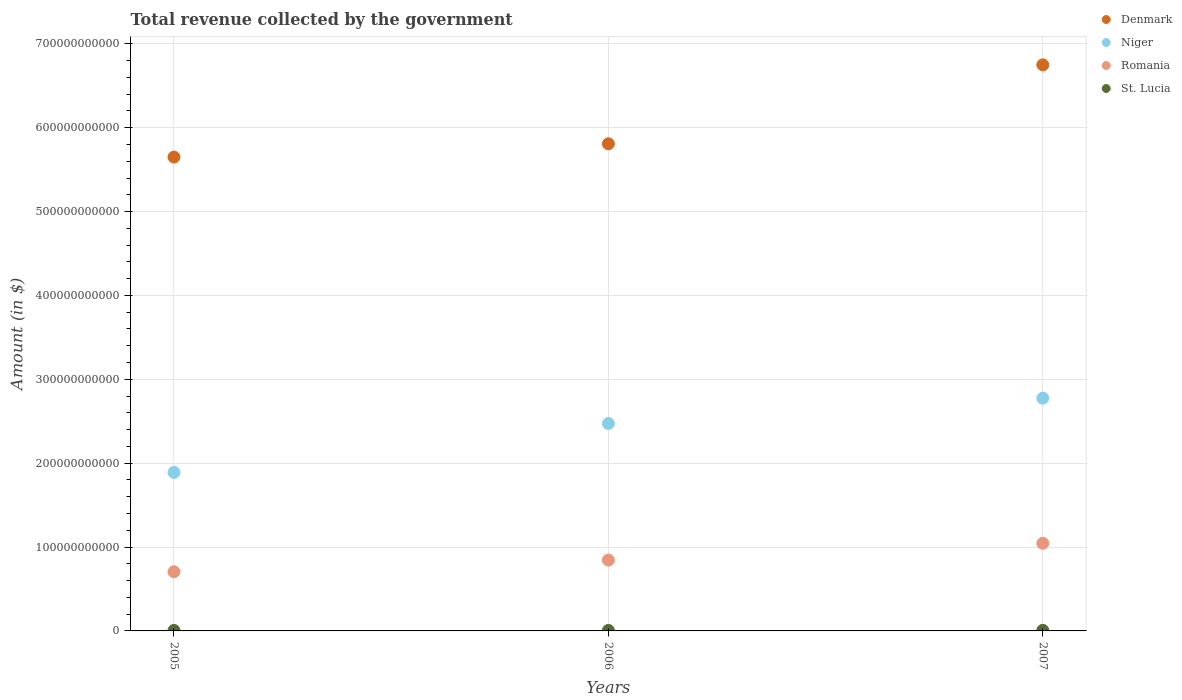What is the total revenue collected by the government in Denmark in 2006?
Offer a terse response. 5.81e+11. Across all years, what is the maximum total revenue collected by the government in St. Lucia?
Your response must be concise. 7.03e+08. Across all years, what is the minimum total revenue collected by the government in Niger?
Your response must be concise. 1.89e+11. In which year was the total revenue collected by the government in Romania maximum?
Your answer should be compact. 2007. What is the total total revenue collected by the government in Romania in the graph?
Offer a terse response. 2.59e+11. What is the difference between the total revenue collected by the government in St. Lucia in 2005 and that in 2006?
Your answer should be compact. -7.08e+07. What is the difference between the total revenue collected by the government in Denmark in 2006 and the total revenue collected by the government in Niger in 2007?
Offer a very short reply. 3.03e+11. What is the average total revenue collected by the government in St. Lucia per year?
Ensure brevity in your answer.  6.43e+08. In the year 2007, what is the difference between the total revenue collected by the government in Romania and total revenue collected by the government in St. Lucia?
Provide a short and direct response. 1.04e+11. In how many years, is the total revenue collected by the government in Romania greater than 460000000000 $?
Ensure brevity in your answer.  0. What is the ratio of the total revenue collected by the government in Denmark in 2005 to that in 2007?
Ensure brevity in your answer.  0.84. Is the total revenue collected by the government in St. Lucia in 2005 less than that in 2007?
Offer a terse response. Yes. What is the difference between the highest and the second highest total revenue collected by the government in Romania?
Your response must be concise. 2.00e+1. What is the difference between the highest and the lowest total revenue collected by the government in Niger?
Make the answer very short. 8.85e+1. Is it the case that in every year, the sum of the total revenue collected by the government in Niger and total revenue collected by the government in Denmark  is greater than the total revenue collected by the government in Romania?
Your answer should be compact. Yes. Does the total revenue collected by the government in St. Lucia monotonically increase over the years?
Make the answer very short. Yes. Is the total revenue collected by the government in Denmark strictly greater than the total revenue collected by the government in Niger over the years?
Make the answer very short. Yes. Is the total revenue collected by the government in St. Lucia strictly less than the total revenue collected by the government in Denmark over the years?
Provide a short and direct response. Yes. How many years are there in the graph?
Ensure brevity in your answer.  3. What is the difference between two consecutive major ticks on the Y-axis?
Make the answer very short. 1.00e+11. Does the graph contain any zero values?
Your answer should be very brief. No. What is the title of the graph?
Make the answer very short. Total revenue collected by the government. Does "Armenia" appear as one of the legend labels in the graph?
Offer a terse response. No. What is the label or title of the Y-axis?
Your answer should be very brief. Amount (in $). What is the Amount (in $) in Denmark in 2005?
Your response must be concise. 5.65e+11. What is the Amount (in $) of Niger in 2005?
Offer a terse response. 1.89e+11. What is the Amount (in $) of Romania in 2005?
Give a very brief answer. 7.06e+1. What is the Amount (in $) of St. Lucia in 2005?
Your answer should be very brief. 5.77e+08. What is the Amount (in $) of Denmark in 2006?
Your answer should be very brief. 5.81e+11. What is the Amount (in $) in Niger in 2006?
Give a very brief answer. 2.47e+11. What is the Amount (in $) in Romania in 2006?
Provide a succinct answer. 8.45e+1. What is the Amount (in $) of St. Lucia in 2006?
Give a very brief answer. 6.48e+08. What is the Amount (in $) in Denmark in 2007?
Keep it short and to the point. 6.75e+11. What is the Amount (in $) of Niger in 2007?
Your response must be concise. 2.78e+11. What is the Amount (in $) in Romania in 2007?
Your response must be concise. 1.04e+11. What is the Amount (in $) of St. Lucia in 2007?
Your answer should be compact. 7.03e+08. Across all years, what is the maximum Amount (in $) in Denmark?
Offer a very short reply. 6.75e+11. Across all years, what is the maximum Amount (in $) of Niger?
Offer a very short reply. 2.78e+11. Across all years, what is the maximum Amount (in $) of Romania?
Offer a very short reply. 1.04e+11. Across all years, what is the maximum Amount (in $) in St. Lucia?
Provide a short and direct response. 7.03e+08. Across all years, what is the minimum Amount (in $) of Denmark?
Ensure brevity in your answer.  5.65e+11. Across all years, what is the minimum Amount (in $) of Niger?
Your response must be concise. 1.89e+11. Across all years, what is the minimum Amount (in $) of Romania?
Provide a succinct answer. 7.06e+1. Across all years, what is the minimum Amount (in $) of St. Lucia?
Your response must be concise. 5.77e+08. What is the total Amount (in $) of Denmark in the graph?
Offer a terse response. 1.82e+12. What is the total Amount (in $) in Niger in the graph?
Offer a terse response. 7.14e+11. What is the total Amount (in $) in Romania in the graph?
Provide a short and direct response. 2.59e+11. What is the total Amount (in $) of St. Lucia in the graph?
Your answer should be compact. 1.93e+09. What is the difference between the Amount (in $) of Denmark in 2005 and that in 2006?
Your response must be concise. -1.59e+1. What is the difference between the Amount (in $) of Niger in 2005 and that in 2006?
Ensure brevity in your answer.  -5.83e+1. What is the difference between the Amount (in $) of Romania in 2005 and that in 2006?
Provide a short and direct response. -1.39e+1. What is the difference between the Amount (in $) of St. Lucia in 2005 and that in 2006?
Ensure brevity in your answer.  -7.08e+07. What is the difference between the Amount (in $) of Denmark in 2005 and that in 2007?
Keep it short and to the point. -1.10e+11. What is the difference between the Amount (in $) in Niger in 2005 and that in 2007?
Offer a terse response. -8.85e+1. What is the difference between the Amount (in $) in Romania in 2005 and that in 2007?
Make the answer very short. -3.39e+1. What is the difference between the Amount (in $) of St. Lucia in 2005 and that in 2007?
Your response must be concise. -1.26e+08. What is the difference between the Amount (in $) in Denmark in 2006 and that in 2007?
Offer a very short reply. -9.41e+1. What is the difference between the Amount (in $) of Niger in 2006 and that in 2007?
Offer a terse response. -3.02e+1. What is the difference between the Amount (in $) of Romania in 2006 and that in 2007?
Keep it short and to the point. -2.00e+1. What is the difference between the Amount (in $) of St. Lucia in 2006 and that in 2007?
Your answer should be compact. -5.57e+07. What is the difference between the Amount (in $) in Denmark in 2005 and the Amount (in $) in Niger in 2006?
Ensure brevity in your answer.  3.18e+11. What is the difference between the Amount (in $) in Denmark in 2005 and the Amount (in $) in Romania in 2006?
Provide a succinct answer. 4.80e+11. What is the difference between the Amount (in $) in Denmark in 2005 and the Amount (in $) in St. Lucia in 2006?
Provide a short and direct response. 5.64e+11. What is the difference between the Amount (in $) of Niger in 2005 and the Amount (in $) of Romania in 2006?
Give a very brief answer. 1.05e+11. What is the difference between the Amount (in $) of Niger in 2005 and the Amount (in $) of St. Lucia in 2006?
Provide a succinct answer. 1.88e+11. What is the difference between the Amount (in $) in Romania in 2005 and the Amount (in $) in St. Lucia in 2006?
Your answer should be very brief. 6.99e+1. What is the difference between the Amount (in $) in Denmark in 2005 and the Amount (in $) in Niger in 2007?
Offer a terse response. 2.87e+11. What is the difference between the Amount (in $) in Denmark in 2005 and the Amount (in $) in Romania in 2007?
Give a very brief answer. 4.60e+11. What is the difference between the Amount (in $) of Denmark in 2005 and the Amount (in $) of St. Lucia in 2007?
Ensure brevity in your answer.  5.64e+11. What is the difference between the Amount (in $) in Niger in 2005 and the Amount (in $) in Romania in 2007?
Your response must be concise. 8.45e+1. What is the difference between the Amount (in $) of Niger in 2005 and the Amount (in $) of St. Lucia in 2007?
Offer a terse response. 1.88e+11. What is the difference between the Amount (in $) in Romania in 2005 and the Amount (in $) in St. Lucia in 2007?
Your response must be concise. 6.98e+1. What is the difference between the Amount (in $) in Denmark in 2006 and the Amount (in $) in Niger in 2007?
Your response must be concise. 3.03e+11. What is the difference between the Amount (in $) of Denmark in 2006 and the Amount (in $) of Romania in 2007?
Ensure brevity in your answer.  4.76e+11. What is the difference between the Amount (in $) of Denmark in 2006 and the Amount (in $) of St. Lucia in 2007?
Keep it short and to the point. 5.80e+11. What is the difference between the Amount (in $) of Niger in 2006 and the Amount (in $) of Romania in 2007?
Provide a succinct answer. 1.43e+11. What is the difference between the Amount (in $) of Niger in 2006 and the Amount (in $) of St. Lucia in 2007?
Provide a short and direct response. 2.47e+11. What is the difference between the Amount (in $) of Romania in 2006 and the Amount (in $) of St. Lucia in 2007?
Offer a very short reply. 8.38e+1. What is the average Amount (in $) in Denmark per year?
Ensure brevity in your answer.  6.07e+11. What is the average Amount (in $) in Niger per year?
Your answer should be compact. 2.38e+11. What is the average Amount (in $) of Romania per year?
Offer a very short reply. 8.65e+1. What is the average Amount (in $) of St. Lucia per year?
Your response must be concise. 6.43e+08. In the year 2005, what is the difference between the Amount (in $) in Denmark and Amount (in $) in Niger?
Your response must be concise. 3.76e+11. In the year 2005, what is the difference between the Amount (in $) in Denmark and Amount (in $) in Romania?
Offer a terse response. 4.94e+11. In the year 2005, what is the difference between the Amount (in $) of Denmark and Amount (in $) of St. Lucia?
Make the answer very short. 5.64e+11. In the year 2005, what is the difference between the Amount (in $) in Niger and Amount (in $) in Romania?
Give a very brief answer. 1.18e+11. In the year 2005, what is the difference between the Amount (in $) in Niger and Amount (in $) in St. Lucia?
Provide a succinct answer. 1.88e+11. In the year 2005, what is the difference between the Amount (in $) of Romania and Amount (in $) of St. Lucia?
Offer a very short reply. 7.00e+1. In the year 2006, what is the difference between the Amount (in $) in Denmark and Amount (in $) in Niger?
Your answer should be compact. 3.34e+11. In the year 2006, what is the difference between the Amount (in $) of Denmark and Amount (in $) of Romania?
Offer a very short reply. 4.96e+11. In the year 2006, what is the difference between the Amount (in $) in Denmark and Amount (in $) in St. Lucia?
Ensure brevity in your answer.  5.80e+11. In the year 2006, what is the difference between the Amount (in $) of Niger and Amount (in $) of Romania?
Keep it short and to the point. 1.63e+11. In the year 2006, what is the difference between the Amount (in $) of Niger and Amount (in $) of St. Lucia?
Offer a very short reply. 2.47e+11. In the year 2006, what is the difference between the Amount (in $) of Romania and Amount (in $) of St. Lucia?
Your response must be concise. 8.38e+1. In the year 2007, what is the difference between the Amount (in $) in Denmark and Amount (in $) in Niger?
Ensure brevity in your answer.  3.97e+11. In the year 2007, what is the difference between the Amount (in $) of Denmark and Amount (in $) of Romania?
Provide a short and direct response. 5.70e+11. In the year 2007, what is the difference between the Amount (in $) of Denmark and Amount (in $) of St. Lucia?
Give a very brief answer. 6.74e+11. In the year 2007, what is the difference between the Amount (in $) of Niger and Amount (in $) of Romania?
Offer a terse response. 1.73e+11. In the year 2007, what is the difference between the Amount (in $) in Niger and Amount (in $) in St. Lucia?
Offer a terse response. 2.77e+11. In the year 2007, what is the difference between the Amount (in $) of Romania and Amount (in $) of St. Lucia?
Ensure brevity in your answer.  1.04e+11. What is the ratio of the Amount (in $) in Denmark in 2005 to that in 2006?
Your answer should be very brief. 0.97. What is the ratio of the Amount (in $) in Niger in 2005 to that in 2006?
Your answer should be very brief. 0.76. What is the ratio of the Amount (in $) of Romania in 2005 to that in 2006?
Ensure brevity in your answer.  0.84. What is the ratio of the Amount (in $) of St. Lucia in 2005 to that in 2006?
Keep it short and to the point. 0.89. What is the ratio of the Amount (in $) of Denmark in 2005 to that in 2007?
Your response must be concise. 0.84. What is the ratio of the Amount (in $) of Niger in 2005 to that in 2007?
Your response must be concise. 0.68. What is the ratio of the Amount (in $) of Romania in 2005 to that in 2007?
Offer a terse response. 0.68. What is the ratio of the Amount (in $) in St. Lucia in 2005 to that in 2007?
Ensure brevity in your answer.  0.82. What is the ratio of the Amount (in $) of Denmark in 2006 to that in 2007?
Your answer should be compact. 0.86. What is the ratio of the Amount (in $) in Niger in 2006 to that in 2007?
Provide a short and direct response. 0.89. What is the ratio of the Amount (in $) of Romania in 2006 to that in 2007?
Offer a terse response. 0.81. What is the ratio of the Amount (in $) in St. Lucia in 2006 to that in 2007?
Keep it short and to the point. 0.92. What is the difference between the highest and the second highest Amount (in $) in Denmark?
Ensure brevity in your answer.  9.41e+1. What is the difference between the highest and the second highest Amount (in $) in Niger?
Keep it short and to the point. 3.02e+1. What is the difference between the highest and the second highest Amount (in $) of Romania?
Provide a succinct answer. 2.00e+1. What is the difference between the highest and the second highest Amount (in $) of St. Lucia?
Your response must be concise. 5.57e+07. What is the difference between the highest and the lowest Amount (in $) in Denmark?
Your response must be concise. 1.10e+11. What is the difference between the highest and the lowest Amount (in $) in Niger?
Your answer should be very brief. 8.85e+1. What is the difference between the highest and the lowest Amount (in $) in Romania?
Keep it short and to the point. 3.39e+1. What is the difference between the highest and the lowest Amount (in $) of St. Lucia?
Offer a very short reply. 1.26e+08. 